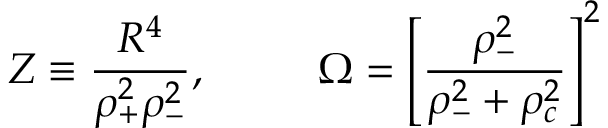<formula> <loc_0><loc_0><loc_500><loc_500>Z \equiv \frac { R ^ { 4 } } { \rho _ { + } ^ { 2 } \rho _ { - } ^ { 2 } } , \, \quad O m e g a = \left [ \frac { \rho _ { - } ^ { 2 } } { \rho _ { - } ^ { 2 } + \rho _ { c } ^ { 2 } } \right ] ^ { 2 }</formula> 